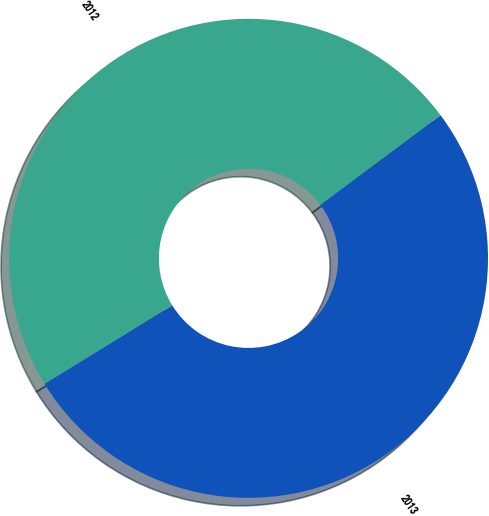Convert chart to OTSL. <chart><loc_0><loc_0><loc_500><loc_500><pie_chart><fcel>2013<fcel>2012<nl><fcel>51.42%<fcel>48.58%<nl></chart> 